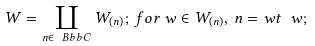<formula> <loc_0><loc_0><loc_500><loc_500>W = \coprod _ { n \in { \ B b b C } } W _ { ( n ) } ; \, f o r \, w \in W _ { ( n ) } , \, n = w t \ w ;</formula> 